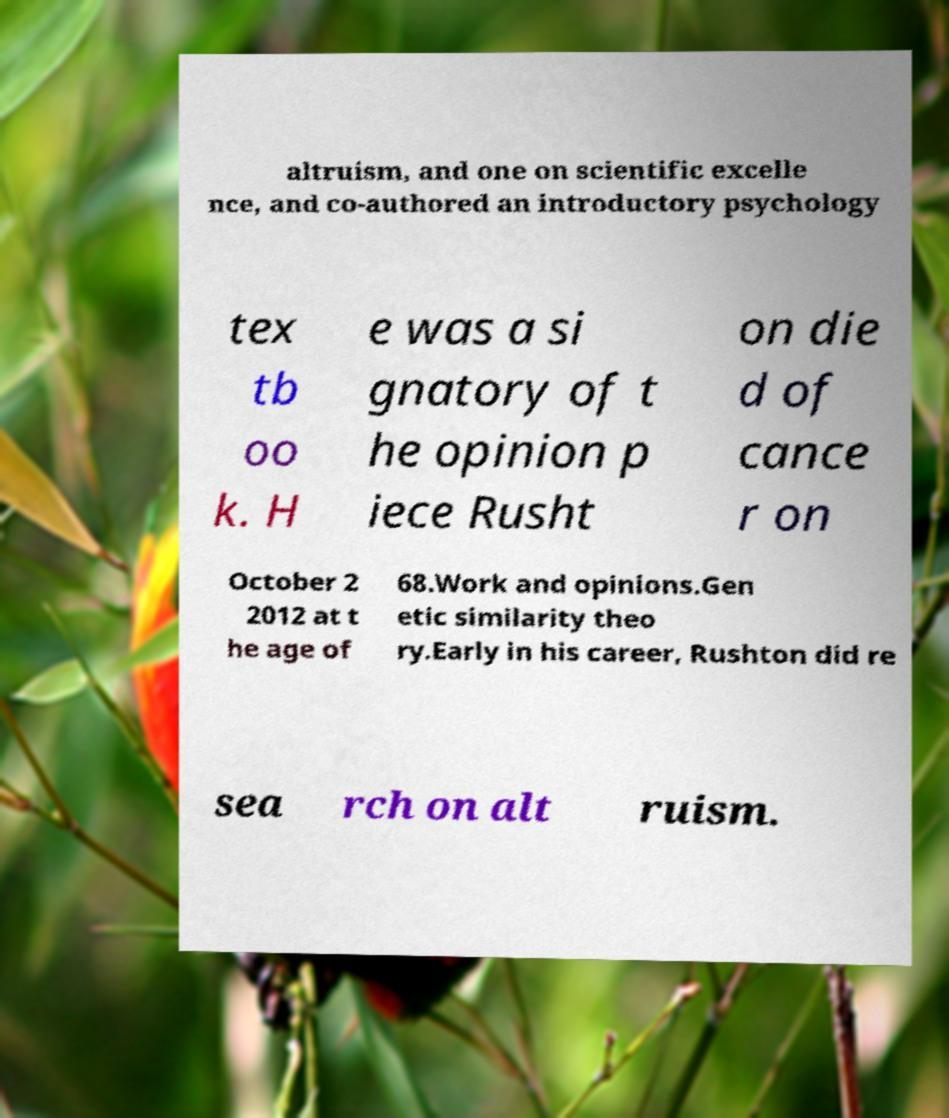Please read and relay the text visible in this image. What does it say? altruism, and one on scientific excelle nce, and co-authored an introductory psychology tex tb oo k. H e was a si gnatory of t he opinion p iece Rusht on die d of cance r on October 2 2012 at t he age of 68.Work and opinions.Gen etic similarity theo ry.Early in his career, Rushton did re sea rch on alt ruism. 